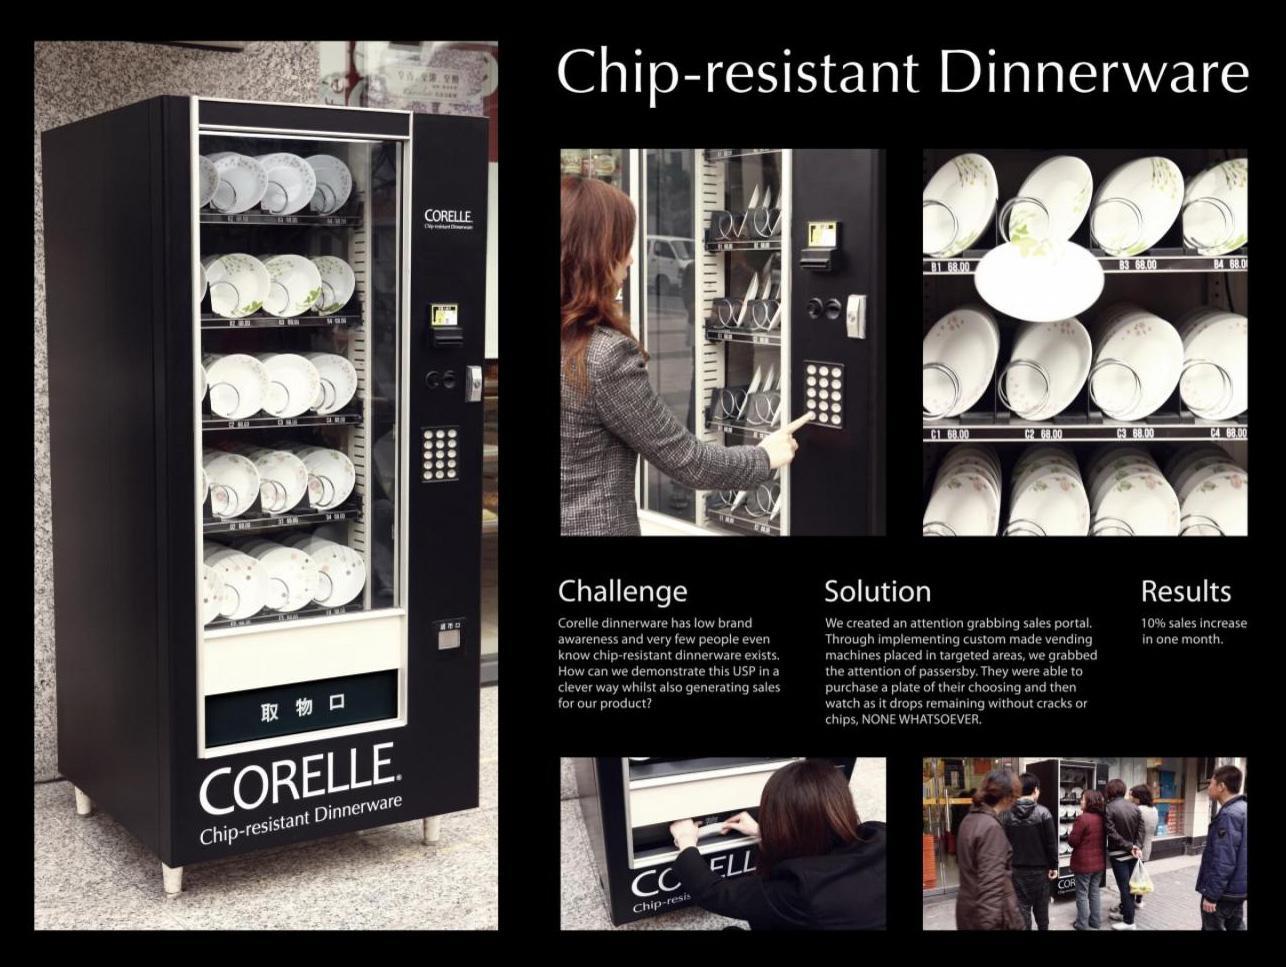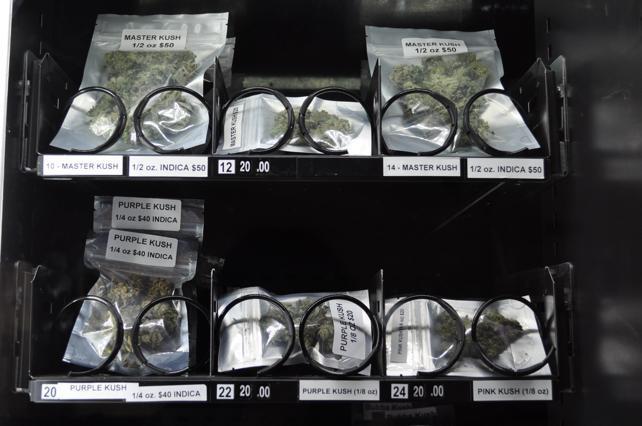The first image is the image on the left, the second image is the image on the right. Examine the images to the left and right. Is the description "One of these machines is red." accurate? Answer yes or no. No. 